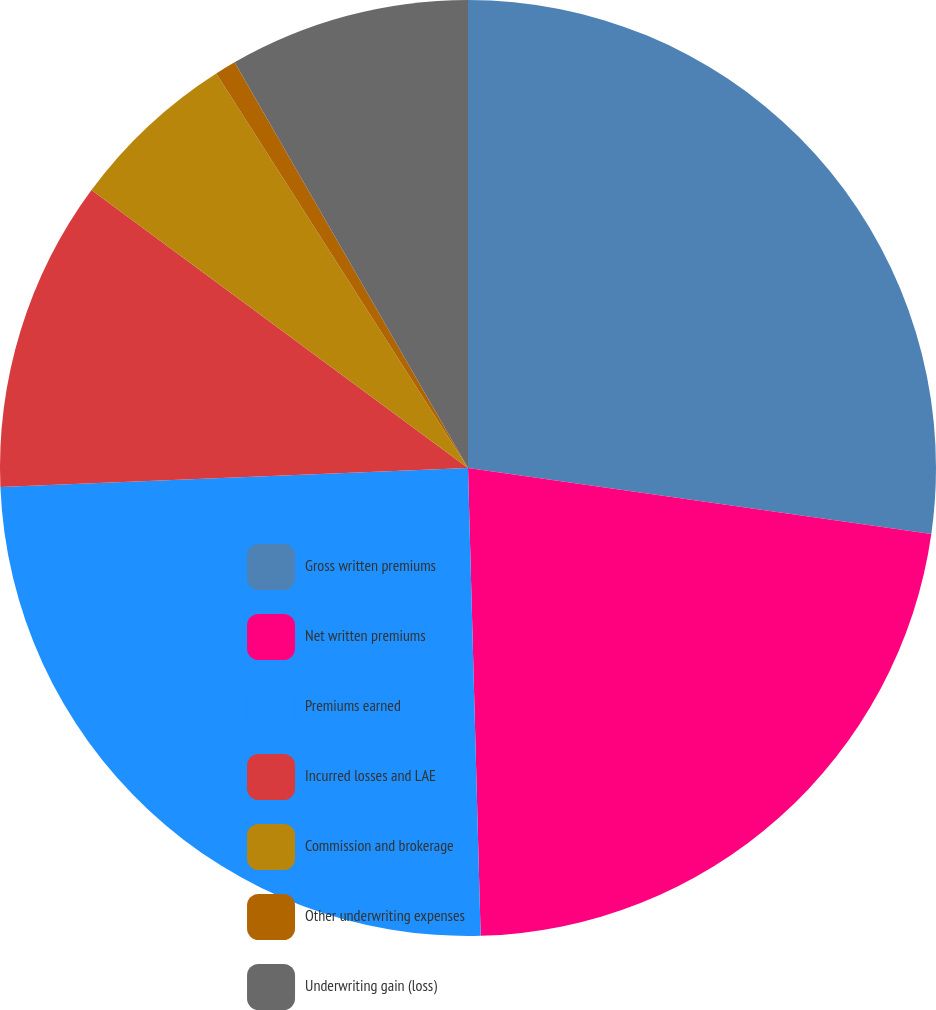Convert chart to OTSL. <chart><loc_0><loc_0><loc_500><loc_500><pie_chart><fcel>Gross written premiums<fcel>Net written premiums<fcel>Premiums earned<fcel>Incurred losses and LAE<fcel>Commission and brokerage<fcel>Other underwriting expenses<fcel>Underwriting gain (loss)<nl><fcel>27.25%<fcel>22.32%<fcel>24.78%<fcel>10.77%<fcel>5.84%<fcel>0.73%<fcel>8.31%<nl></chart> 